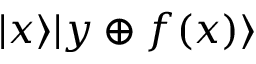<formula> <loc_0><loc_0><loc_500><loc_500>| x \rangle | y \oplus f ( x ) \rangle</formula> 